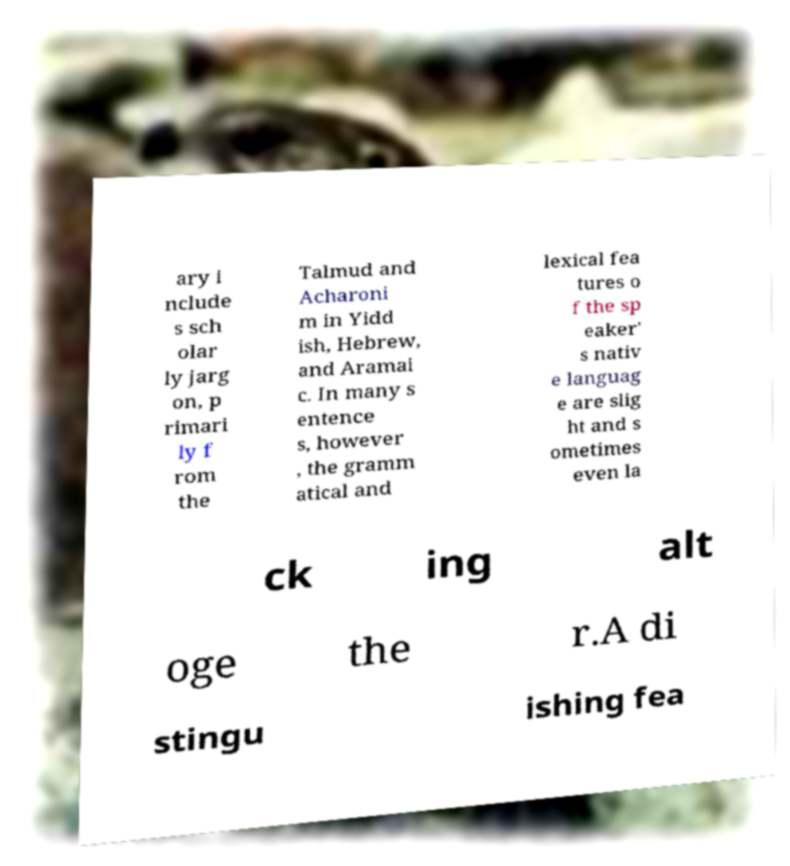For documentation purposes, I need the text within this image transcribed. Could you provide that? ary i nclude s sch olar ly jarg on, p rimari ly f rom the Talmud and Acharoni m in Yidd ish, Hebrew, and Aramai c. In many s entence s, however , the gramm atical and lexical fea tures o f the sp eaker' s nativ e languag e are slig ht and s ometimes even la ck ing alt oge the r.A di stingu ishing fea 